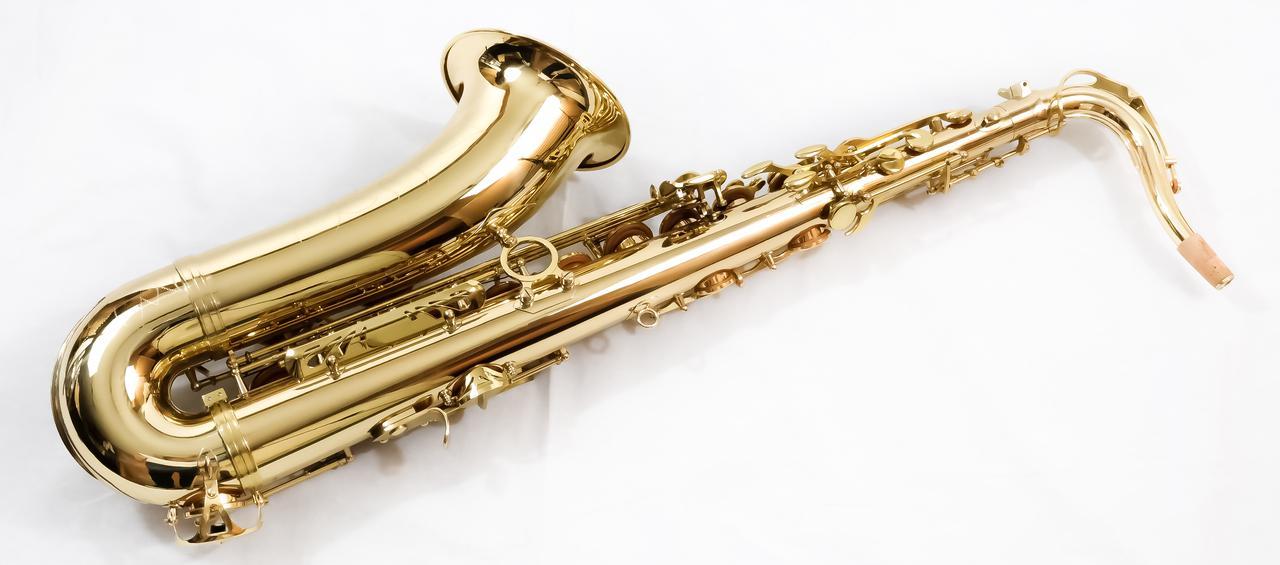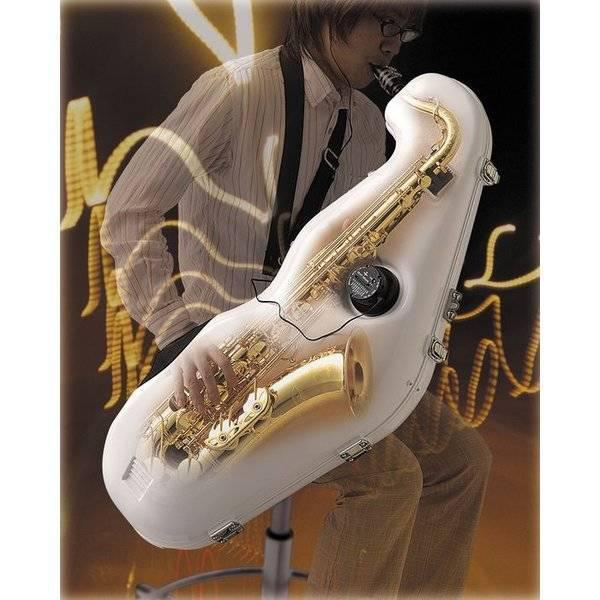The first image is the image on the left, the second image is the image on the right. Evaluate the accuracy of this statement regarding the images: "In at least on image there is a brass saxophone facing left with it black case behind it.". Is it true? Answer yes or no. No. The first image is the image on the left, the second image is the image on the right. For the images displayed, is the sentence "In the image on the right, one of the saxophones is sitting next to a closed case, while the other saxophone is sitting inside an open case." factually correct? Answer yes or no. No. 